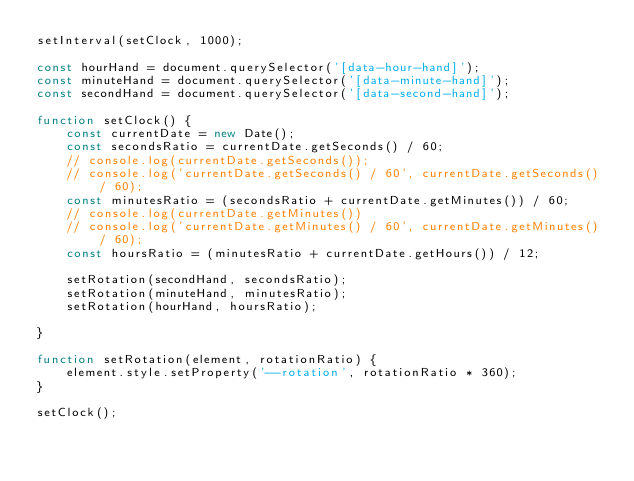Convert code to text. <code><loc_0><loc_0><loc_500><loc_500><_JavaScript_>setInterval(setClock, 1000);

const hourHand = document.querySelector('[data-hour-hand]');
const minuteHand = document.querySelector('[data-minute-hand]');
const secondHand = document.querySelector('[data-second-hand]');

function setClock() {
    const currentDate = new Date();
    const secondsRatio = currentDate.getSeconds() / 60;
    // console.log(currentDate.getSeconds());
    // console.log('currentDate.getSeconds() / 60', currentDate.getSeconds() / 60);
    const minutesRatio = (secondsRatio + currentDate.getMinutes()) / 60;
    // console.log(currentDate.getMinutes())
    // console.log('currentDate.getMinutes() / 60', currentDate.getMinutes() / 60);
    const hoursRatio = (minutesRatio + currentDate.getHours()) / 12;

    setRotation(secondHand, secondsRatio);
    setRotation(minuteHand, minutesRatio);
    setRotation(hourHand, hoursRatio);

}

function setRotation(element, rotationRatio) {
    element.style.setProperty('--rotation', rotationRatio * 360);
}

setClock();

</code> 